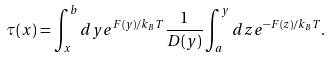<formula> <loc_0><loc_0><loc_500><loc_500>\tau ( x ) = \int ^ { b } _ { x } d y e ^ { F ( y ) / k _ { B } T } \frac { 1 } { D ( y ) } \int ^ { y } _ { a } d z e ^ { - F ( z ) / k _ { B } T } .</formula> 